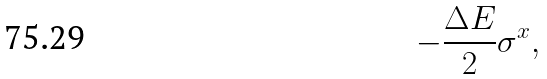<formula> <loc_0><loc_0><loc_500><loc_500>- \frac { \Delta E } { 2 } \sigma ^ { x } ,</formula> 